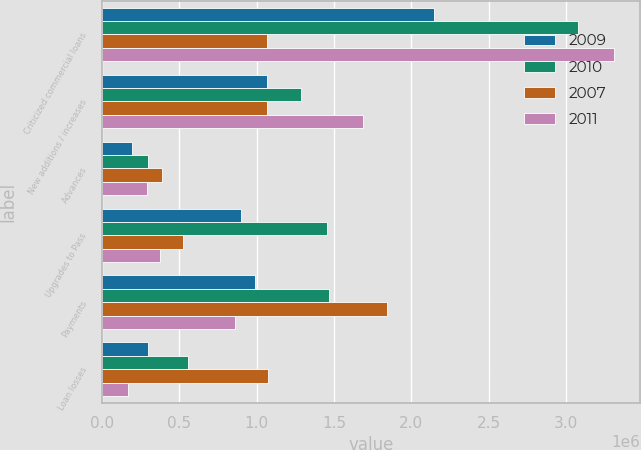Convert chart to OTSL. <chart><loc_0><loc_0><loc_500><loc_500><stacked_bar_chart><ecel><fcel>Criticized commercial loans<fcel>New additions / increases<fcel>Advances<fcel>Upgrades to Pass<fcel>Payments<fcel>Loan losses<nl><fcel>2009<fcel>2.14661e+06<fcel>1.0683e+06<fcel>193679<fcel>901633<fcel>986919<fcel>301300<nl><fcel>2010<fcel>3.07448e+06<fcel>1.28422e+06<fcel>298511<fcel>1.45613e+06<fcel>1.46537e+06<fcel>558377<nl><fcel>2007<fcel>1.0683e+06<fcel>1.0683e+06<fcel>390872<fcel>522150<fcel>1.84354e+06<fcel>1.07235e+06<nl><fcel>2011<fcel>3.31128e+06<fcel>1.68802e+06<fcel>292295<fcel>378027<fcel>858996<fcel>168180<nl></chart> 